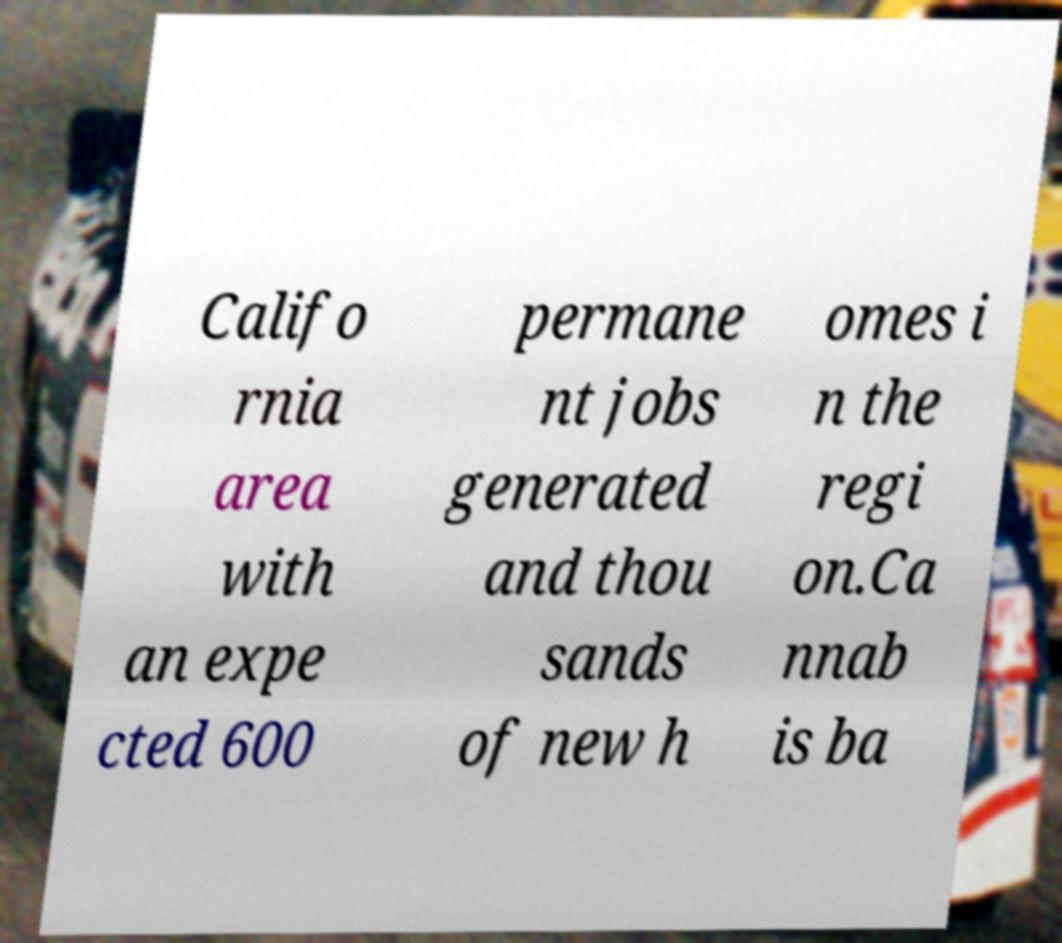For documentation purposes, I need the text within this image transcribed. Could you provide that? Califo rnia area with an expe cted 600 permane nt jobs generated and thou sands of new h omes i n the regi on.Ca nnab is ba 